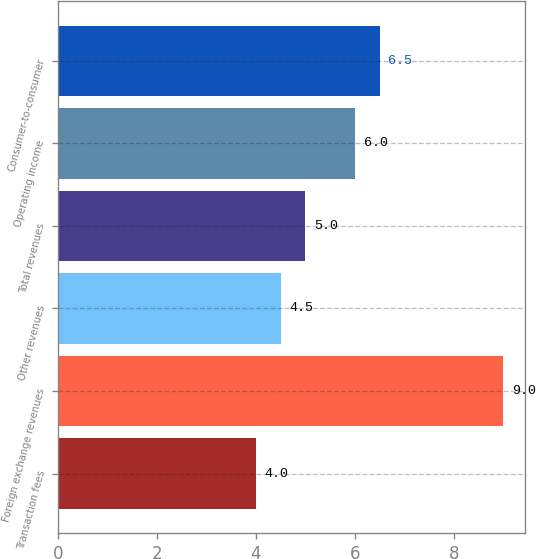Convert chart to OTSL. <chart><loc_0><loc_0><loc_500><loc_500><bar_chart><fcel>Transaction fees<fcel>Foreign exchange revenues<fcel>Other revenues<fcel>Total revenues<fcel>Operating income<fcel>Consumer-to-consumer<nl><fcel>4<fcel>9<fcel>4.5<fcel>5<fcel>6<fcel>6.5<nl></chart> 